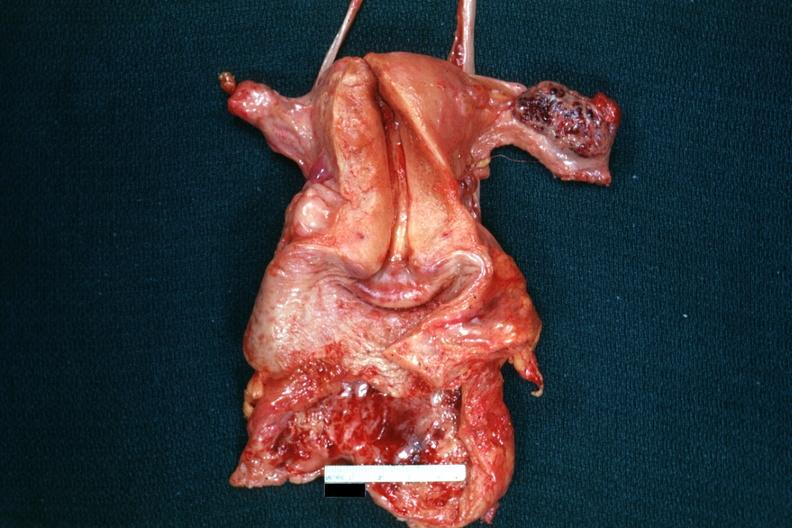s heart present?
Answer the question using a single word or phrase. No 